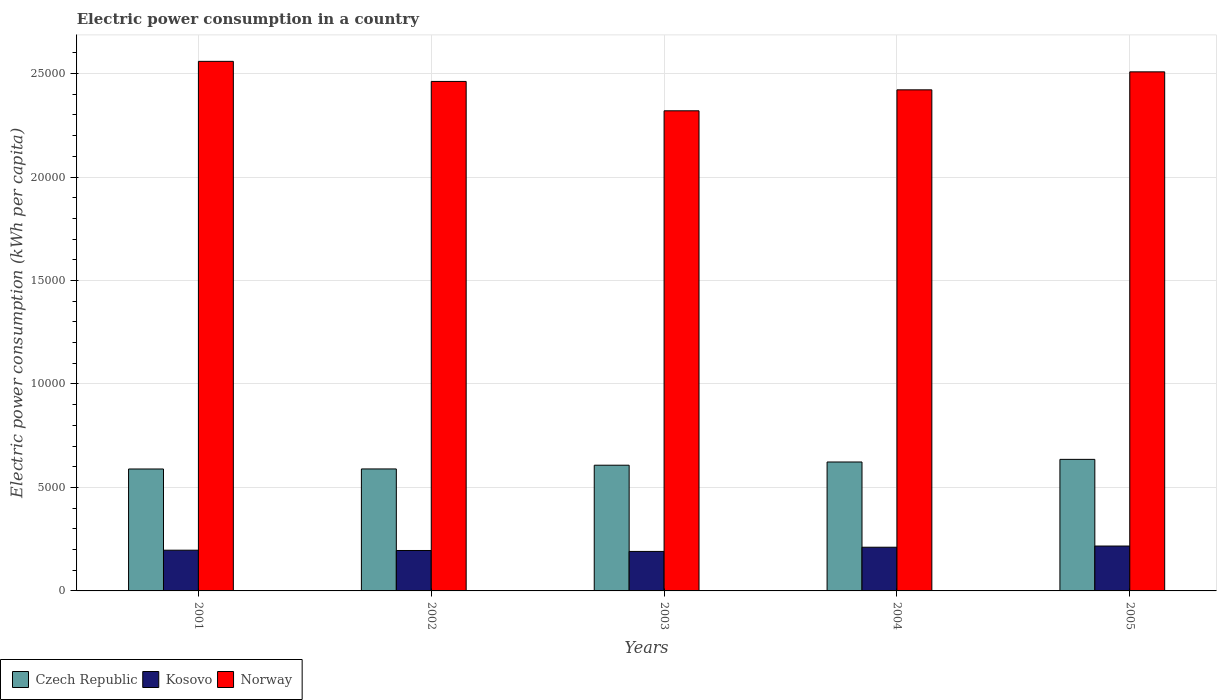How many bars are there on the 5th tick from the left?
Offer a very short reply. 3. How many bars are there on the 5th tick from the right?
Give a very brief answer. 3. What is the electric power consumption in in Czech Republic in 2005?
Your answer should be compact. 6357.42. Across all years, what is the maximum electric power consumption in in Kosovo?
Provide a succinct answer. 2169.1. Across all years, what is the minimum electric power consumption in in Czech Republic?
Give a very brief answer. 5892.17. In which year was the electric power consumption in in Norway maximum?
Give a very brief answer. 2001. In which year was the electric power consumption in in Kosovo minimum?
Provide a short and direct response. 2003. What is the total electric power consumption in in Norway in the graph?
Provide a short and direct response. 1.23e+05. What is the difference between the electric power consumption in in Kosovo in 2003 and that in 2005?
Your response must be concise. -260.63. What is the difference between the electric power consumption in in Czech Republic in 2001 and the electric power consumption in in Norway in 2002?
Provide a succinct answer. -1.87e+04. What is the average electric power consumption in in Czech Republic per year?
Ensure brevity in your answer.  6089.81. In the year 2002, what is the difference between the electric power consumption in in Kosovo and electric power consumption in in Norway?
Your answer should be compact. -2.27e+04. What is the ratio of the electric power consumption in in Czech Republic in 2002 to that in 2003?
Give a very brief answer. 0.97. Is the difference between the electric power consumption in in Kosovo in 2004 and 2005 greater than the difference between the electric power consumption in in Norway in 2004 and 2005?
Provide a short and direct response. Yes. What is the difference between the highest and the second highest electric power consumption in in Kosovo?
Your answer should be very brief. 57.78. What is the difference between the highest and the lowest electric power consumption in in Norway?
Your answer should be compact. 2389.3. Is the sum of the electric power consumption in in Norway in 2001 and 2004 greater than the maximum electric power consumption in in Czech Republic across all years?
Offer a terse response. Yes. What does the 1st bar from the left in 2001 represents?
Your answer should be very brief. Czech Republic. Are all the bars in the graph horizontal?
Make the answer very short. No. How many years are there in the graph?
Keep it short and to the point. 5. Where does the legend appear in the graph?
Offer a very short reply. Bottom left. How are the legend labels stacked?
Your answer should be compact. Horizontal. What is the title of the graph?
Make the answer very short. Electric power consumption in a country. Does "Panama" appear as one of the legend labels in the graph?
Offer a terse response. No. What is the label or title of the X-axis?
Provide a succinct answer. Years. What is the label or title of the Y-axis?
Provide a succinct answer. Electric power consumption (kWh per capita). What is the Electric power consumption (kWh per capita) of Czech Republic in 2001?
Keep it short and to the point. 5892.17. What is the Electric power consumption (kWh per capita) in Kosovo in 2001?
Give a very brief answer. 1968.08. What is the Electric power consumption (kWh per capita) of Norway in 2001?
Your response must be concise. 2.56e+04. What is the Electric power consumption (kWh per capita) in Czech Republic in 2002?
Your answer should be compact. 5894.23. What is the Electric power consumption (kWh per capita) in Kosovo in 2002?
Make the answer very short. 1953.82. What is the Electric power consumption (kWh per capita) in Norway in 2002?
Your answer should be compact. 2.46e+04. What is the Electric power consumption (kWh per capita) in Czech Republic in 2003?
Provide a succinct answer. 6074.85. What is the Electric power consumption (kWh per capita) in Kosovo in 2003?
Offer a very short reply. 1908.46. What is the Electric power consumption (kWh per capita) in Norway in 2003?
Give a very brief answer. 2.32e+04. What is the Electric power consumption (kWh per capita) of Czech Republic in 2004?
Keep it short and to the point. 6230.4. What is the Electric power consumption (kWh per capita) in Kosovo in 2004?
Your answer should be very brief. 2111.32. What is the Electric power consumption (kWh per capita) of Norway in 2004?
Ensure brevity in your answer.  2.42e+04. What is the Electric power consumption (kWh per capita) in Czech Republic in 2005?
Your answer should be compact. 6357.42. What is the Electric power consumption (kWh per capita) of Kosovo in 2005?
Your answer should be very brief. 2169.1. What is the Electric power consumption (kWh per capita) of Norway in 2005?
Offer a terse response. 2.51e+04. Across all years, what is the maximum Electric power consumption (kWh per capita) in Czech Republic?
Provide a short and direct response. 6357.42. Across all years, what is the maximum Electric power consumption (kWh per capita) in Kosovo?
Offer a very short reply. 2169.1. Across all years, what is the maximum Electric power consumption (kWh per capita) of Norway?
Provide a short and direct response. 2.56e+04. Across all years, what is the minimum Electric power consumption (kWh per capita) in Czech Republic?
Ensure brevity in your answer.  5892.17. Across all years, what is the minimum Electric power consumption (kWh per capita) of Kosovo?
Offer a terse response. 1908.46. Across all years, what is the minimum Electric power consumption (kWh per capita) of Norway?
Provide a short and direct response. 2.32e+04. What is the total Electric power consumption (kWh per capita) in Czech Republic in the graph?
Offer a terse response. 3.04e+04. What is the total Electric power consumption (kWh per capita) in Kosovo in the graph?
Ensure brevity in your answer.  1.01e+04. What is the total Electric power consumption (kWh per capita) of Norway in the graph?
Offer a very short reply. 1.23e+05. What is the difference between the Electric power consumption (kWh per capita) of Czech Republic in 2001 and that in 2002?
Give a very brief answer. -2.06. What is the difference between the Electric power consumption (kWh per capita) in Kosovo in 2001 and that in 2002?
Provide a short and direct response. 14.26. What is the difference between the Electric power consumption (kWh per capita) of Norway in 2001 and that in 2002?
Your answer should be compact. 970.35. What is the difference between the Electric power consumption (kWh per capita) of Czech Republic in 2001 and that in 2003?
Provide a short and direct response. -182.68. What is the difference between the Electric power consumption (kWh per capita) of Kosovo in 2001 and that in 2003?
Give a very brief answer. 59.61. What is the difference between the Electric power consumption (kWh per capita) of Norway in 2001 and that in 2003?
Ensure brevity in your answer.  2389.3. What is the difference between the Electric power consumption (kWh per capita) of Czech Republic in 2001 and that in 2004?
Ensure brevity in your answer.  -338.23. What is the difference between the Electric power consumption (kWh per capita) in Kosovo in 2001 and that in 2004?
Ensure brevity in your answer.  -143.24. What is the difference between the Electric power consumption (kWh per capita) of Norway in 2001 and that in 2004?
Keep it short and to the point. 1376.58. What is the difference between the Electric power consumption (kWh per capita) in Czech Republic in 2001 and that in 2005?
Make the answer very short. -465.25. What is the difference between the Electric power consumption (kWh per capita) of Kosovo in 2001 and that in 2005?
Make the answer very short. -201.02. What is the difference between the Electric power consumption (kWh per capita) of Norway in 2001 and that in 2005?
Offer a terse response. 507.47. What is the difference between the Electric power consumption (kWh per capita) of Czech Republic in 2002 and that in 2003?
Offer a very short reply. -180.62. What is the difference between the Electric power consumption (kWh per capita) of Kosovo in 2002 and that in 2003?
Your response must be concise. 45.35. What is the difference between the Electric power consumption (kWh per capita) of Norway in 2002 and that in 2003?
Provide a succinct answer. 1418.94. What is the difference between the Electric power consumption (kWh per capita) of Czech Republic in 2002 and that in 2004?
Make the answer very short. -336.17. What is the difference between the Electric power consumption (kWh per capita) of Kosovo in 2002 and that in 2004?
Your answer should be compact. -157.5. What is the difference between the Electric power consumption (kWh per capita) in Norway in 2002 and that in 2004?
Offer a very short reply. 406.23. What is the difference between the Electric power consumption (kWh per capita) in Czech Republic in 2002 and that in 2005?
Offer a very short reply. -463.19. What is the difference between the Electric power consumption (kWh per capita) of Kosovo in 2002 and that in 2005?
Ensure brevity in your answer.  -215.28. What is the difference between the Electric power consumption (kWh per capita) in Norway in 2002 and that in 2005?
Offer a very short reply. -462.88. What is the difference between the Electric power consumption (kWh per capita) in Czech Republic in 2003 and that in 2004?
Provide a short and direct response. -155.55. What is the difference between the Electric power consumption (kWh per capita) in Kosovo in 2003 and that in 2004?
Your response must be concise. -202.86. What is the difference between the Electric power consumption (kWh per capita) of Norway in 2003 and that in 2004?
Make the answer very short. -1012.71. What is the difference between the Electric power consumption (kWh per capita) in Czech Republic in 2003 and that in 2005?
Your answer should be very brief. -282.57. What is the difference between the Electric power consumption (kWh per capita) in Kosovo in 2003 and that in 2005?
Your response must be concise. -260.63. What is the difference between the Electric power consumption (kWh per capita) of Norway in 2003 and that in 2005?
Offer a very short reply. -1881.82. What is the difference between the Electric power consumption (kWh per capita) of Czech Republic in 2004 and that in 2005?
Provide a short and direct response. -127.02. What is the difference between the Electric power consumption (kWh per capita) of Kosovo in 2004 and that in 2005?
Your answer should be compact. -57.78. What is the difference between the Electric power consumption (kWh per capita) in Norway in 2004 and that in 2005?
Ensure brevity in your answer.  -869.11. What is the difference between the Electric power consumption (kWh per capita) in Czech Republic in 2001 and the Electric power consumption (kWh per capita) in Kosovo in 2002?
Give a very brief answer. 3938.36. What is the difference between the Electric power consumption (kWh per capita) of Czech Republic in 2001 and the Electric power consumption (kWh per capita) of Norway in 2002?
Offer a terse response. -1.87e+04. What is the difference between the Electric power consumption (kWh per capita) in Kosovo in 2001 and the Electric power consumption (kWh per capita) in Norway in 2002?
Make the answer very short. -2.27e+04. What is the difference between the Electric power consumption (kWh per capita) of Czech Republic in 2001 and the Electric power consumption (kWh per capita) of Kosovo in 2003?
Make the answer very short. 3983.71. What is the difference between the Electric power consumption (kWh per capita) in Czech Republic in 2001 and the Electric power consumption (kWh per capita) in Norway in 2003?
Your answer should be very brief. -1.73e+04. What is the difference between the Electric power consumption (kWh per capita) of Kosovo in 2001 and the Electric power consumption (kWh per capita) of Norway in 2003?
Offer a terse response. -2.12e+04. What is the difference between the Electric power consumption (kWh per capita) of Czech Republic in 2001 and the Electric power consumption (kWh per capita) of Kosovo in 2004?
Your answer should be very brief. 3780.85. What is the difference between the Electric power consumption (kWh per capita) in Czech Republic in 2001 and the Electric power consumption (kWh per capita) in Norway in 2004?
Offer a terse response. -1.83e+04. What is the difference between the Electric power consumption (kWh per capita) in Kosovo in 2001 and the Electric power consumption (kWh per capita) in Norway in 2004?
Your response must be concise. -2.22e+04. What is the difference between the Electric power consumption (kWh per capita) in Czech Republic in 2001 and the Electric power consumption (kWh per capita) in Kosovo in 2005?
Ensure brevity in your answer.  3723.08. What is the difference between the Electric power consumption (kWh per capita) of Czech Republic in 2001 and the Electric power consumption (kWh per capita) of Norway in 2005?
Provide a succinct answer. -1.92e+04. What is the difference between the Electric power consumption (kWh per capita) of Kosovo in 2001 and the Electric power consumption (kWh per capita) of Norway in 2005?
Keep it short and to the point. -2.31e+04. What is the difference between the Electric power consumption (kWh per capita) in Czech Republic in 2002 and the Electric power consumption (kWh per capita) in Kosovo in 2003?
Your answer should be compact. 3985.77. What is the difference between the Electric power consumption (kWh per capita) of Czech Republic in 2002 and the Electric power consumption (kWh per capita) of Norway in 2003?
Offer a very short reply. -1.73e+04. What is the difference between the Electric power consumption (kWh per capita) in Kosovo in 2002 and the Electric power consumption (kWh per capita) in Norway in 2003?
Offer a terse response. -2.12e+04. What is the difference between the Electric power consumption (kWh per capita) of Czech Republic in 2002 and the Electric power consumption (kWh per capita) of Kosovo in 2004?
Offer a very short reply. 3782.91. What is the difference between the Electric power consumption (kWh per capita) in Czech Republic in 2002 and the Electric power consumption (kWh per capita) in Norway in 2004?
Offer a terse response. -1.83e+04. What is the difference between the Electric power consumption (kWh per capita) in Kosovo in 2002 and the Electric power consumption (kWh per capita) in Norway in 2004?
Provide a succinct answer. -2.23e+04. What is the difference between the Electric power consumption (kWh per capita) in Czech Republic in 2002 and the Electric power consumption (kWh per capita) in Kosovo in 2005?
Keep it short and to the point. 3725.14. What is the difference between the Electric power consumption (kWh per capita) of Czech Republic in 2002 and the Electric power consumption (kWh per capita) of Norway in 2005?
Ensure brevity in your answer.  -1.92e+04. What is the difference between the Electric power consumption (kWh per capita) in Kosovo in 2002 and the Electric power consumption (kWh per capita) in Norway in 2005?
Provide a succinct answer. -2.31e+04. What is the difference between the Electric power consumption (kWh per capita) in Czech Republic in 2003 and the Electric power consumption (kWh per capita) in Kosovo in 2004?
Your response must be concise. 3963.53. What is the difference between the Electric power consumption (kWh per capita) of Czech Republic in 2003 and the Electric power consumption (kWh per capita) of Norway in 2004?
Your answer should be very brief. -1.81e+04. What is the difference between the Electric power consumption (kWh per capita) of Kosovo in 2003 and the Electric power consumption (kWh per capita) of Norway in 2004?
Ensure brevity in your answer.  -2.23e+04. What is the difference between the Electric power consumption (kWh per capita) of Czech Republic in 2003 and the Electric power consumption (kWh per capita) of Kosovo in 2005?
Your response must be concise. 3905.75. What is the difference between the Electric power consumption (kWh per capita) of Czech Republic in 2003 and the Electric power consumption (kWh per capita) of Norway in 2005?
Provide a short and direct response. -1.90e+04. What is the difference between the Electric power consumption (kWh per capita) in Kosovo in 2003 and the Electric power consumption (kWh per capita) in Norway in 2005?
Give a very brief answer. -2.32e+04. What is the difference between the Electric power consumption (kWh per capita) of Czech Republic in 2004 and the Electric power consumption (kWh per capita) of Kosovo in 2005?
Keep it short and to the point. 4061.3. What is the difference between the Electric power consumption (kWh per capita) in Czech Republic in 2004 and the Electric power consumption (kWh per capita) in Norway in 2005?
Offer a very short reply. -1.89e+04. What is the difference between the Electric power consumption (kWh per capita) of Kosovo in 2004 and the Electric power consumption (kWh per capita) of Norway in 2005?
Ensure brevity in your answer.  -2.30e+04. What is the average Electric power consumption (kWh per capita) of Czech Republic per year?
Give a very brief answer. 6089.81. What is the average Electric power consumption (kWh per capita) of Kosovo per year?
Keep it short and to the point. 2022.15. What is the average Electric power consumption (kWh per capita) in Norway per year?
Your answer should be compact. 2.45e+04. In the year 2001, what is the difference between the Electric power consumption (kWh per capita) of Czech Republic and Electric power consumption (kWh per capita) of Kosovo?
Give a very brief answer. 3924.1. In the year 2001, what is the difference between the Electric power consumption (kWh per capita) in Czech Republic and Electric power consumption (kWh per capita) in Norway?
Ensure brevity in your answer.  -1.97e+04. In the year 2001, what is the difference between the Electric power consumption (kWh per capita) in Kosovo and Electric power consumption (kWh per capita) in Norway?
Offer a terse response. -2.36e+04. In the year 2002, what is the difference between the Electric power consumption (kWh per capita) in Czech Republic and Electric power consumption (kWh per capita) in Kosovo?
Your response must be concise. 3940.42. In the year 2002, what is the difference between the Electric power consumption (kWh per capita) of Czech Republic and Electric power consumption (kWh per capita) of Norway?
Provide a succinct answer. -1.87e+04. In the year 2002, what is the difference between the Electric power consumption (kWh per capita) of Kosovo and Electric power consumption (kWh per capita) of Norway?
Give a very brief answer. -2.27e+04. In the year 2003, what is the difference between the Electric power consumption (kWh per capita) of Czech Republic and Electric power consumption (kWh per capita) of Kosovo?
Offer a terse response. 4166.39. In the year 2003, what is the difference between the Electric power consumption (kWh per capita) in Czech Republic and Electric power consumption (kWh per capita) in Norway?
Provide a succinct answer. -1.71e+04. In the year 2003, what is the difference between the Electric power consumption (kWh per capita) in Kosovo and Electric power consumption (kWh per capita) in Norway?
Offer a terse response. -2.13e+04. In the year 2004, what is the difference between the Electric power consumption (kWh per capita) of Czech Republic and Electric power consumption (kWh per capita) of Kosovo?
Keep it short and to the point. 4119.08. In the year 2004, what is the difference between the Electric power consumption (kWh per capita) in Czech Republic and Electric power consumption (kWh per capita) in Norway?
Give a very brief answer. -1.80e+04. In the year 2004, what is the difference between the Electric power consumption (kWh per capita) in Kosovo and Electric power consumption (kWh per capita) in Norway?
Ensure brevity in your answer.  -2.21e+04. In the year 2005, what is the difference between the Electric power consumption (kWh per capita) of Czech Republic and Electric power consumption (kWh per capita) of Kosovo?
Your answer should be compact. 4188.33. In the year 2005, what is the difference between the Electric power consumption (kWh per capita) of Czech Republic and Electric power consumption (kWh per capita) of Norway?
Offer a terse response. -1.87e+04. In the year 2005, what is the difference between the Electric power consumption (kWh per capita) of Kosovo and Electric power consumption (kWh per capita) of Norway?
Your answer should be very brief. -2.29e+04. What is the ratio of the Electric power consumption (kWh per capita) of Czech Republic in 2001 to that in 2002?
Provide a short and direct response. 1. What is the ratio of the Electric power consumption (kWh per capita) in Kosovo in 2001 to that in 2002?
Provide a short and direct response. 1.01. What is the ratio of the Electric power consumption (kWh per capita) of Norway in 2001 to that in 2002?
Ensure brevity in your answer.  1.04. What is the ratio of the Electric power consumption (kWh per capita) in Czech Republic in 2001 to that in 2003?
Make the answer very short. 0.97. What is the ratio of the Electric power consumption (kWh per capita) in Kosovo in 2001 to that in 2003?
Provide a succinct answer. 1.03. What is the ratio of the Electric power consumption (kWh per capita) in Norway in 2001 to that in 2003?
Ensure brevity in your answer.  1.1. What is the ratio of the Electric power consumption (kWh per capita) in Czech Republic in 2001 to that in 2004?
Your answer should be compact. 0.95. What is the ratio of the Electric power consumption (kWh per capita) of Kosovo in 2001 to that in 2004?
Give a very brief answer. 0.93. What is the ratio of the Electric power consumption (kWh per capita) in Norway in 2001 to that in 2004?
Offer a very short reply. 1.06. What is the ratio of the Electric power consumption (kWh per capita) in Czech Republic in 2001 to that in 2005?
Offer a very short reply. 0.93. What is the ratio of the Electric power consumption (kWh per capita) in Kosovo in 2001 to that in 2005?
Provide a succinct answer. 0.91. What is the ratio of the Electric power consumption (kWh per capita) in Norway in 2001 to that in 2005?
Provide a short and direct response. 1.02. What is the ratio of the Electric power consumption (kWh per capita) in Czech Republic in 2002 to that in 2003?
Your response must be concise. 0.97. What is the ratio of the Electric power consumption (kWh per capita) in Kosovo in 2002 to that in 2003?
Your answer should be very brief. 1.02. What is the ratio of the Electric power consumption (kWh per capita) of Norway in 2002 to that in 2003?
Provide a succinct answer. 1.06. What is the ratio of the Electric power consumption (kWh per capita) of Czech Republic in 2002 to that in 2004?
Your answer should be very brief. 0.95. What is the ratio of the Electric power consumption (kWh per capita) in Kosovo in 2002 to that in 2004?
Offer a terse response. 0.93. What is the ratio of the Electric power consumption (kWh per capita) of Norway in 2002 to that in 2004?
Provide a short and direct response. 1.02. What is the ratio of the Electric power consumption (kWh per capita) of Czech Republic in 2002 to that in 2005?
Your response must be concise. 0.93. What is the ratio of the Electric power consumption (kWh per capita) in Kosovo in 2002 to that in 2005?
Your answer should be very brief. 0.9. What is the ratio of the Electric power consumption (kWh per capita) in Norway in 2002 to that in 2005?
Provide a succinct answer. 0.98. What is the ratio of the Electric power consumption (kWh per capita) of Kosovo in 2003 to that in 2004?
Your response must be concise. 0.9. What is the ratio of the Electric power consumption (kWh per capita) in Norway in 2003 to that in 2004?
Ensure brevity in your answer.  0.96. What is the ratio of the Electric power consumption (kWh per capita) in Czech Republic in 2003 to that in 2005?
Keep it short and to the point. 0.96. What is the ratio of the Electric power consumption (kWh per capita) in Kosovo in 2003 to that in 2005?
Make the answer very short. 0.88. What is the ratio of the Electric power consumption (kWh per capita) of Norway in 2003 to that in 2005?
Give a very brief answer. 0.93. What is the ratio of the Electric power consumption (kWh per capita) of Kosovo in 2004 to that in 2005?
Ensure brevity in your answer.  0.97. What is the ratio of the Electric power consumption (kWh per capita) of Norway in 2004 to that in 2005?
Your answer should be very brief. 0.97. What is the difference between the highest and the second highest Electric power consumption (kWh per capita) in Czech Republic?
Give a very brief answer. 127.02. What is the difference between the highest and the second highest Electric power consumption (kWh per capita) in Kosovo?
Make the answer very short. 57.78. What is the difference between the highest and the second highest Electric power consumption (kWh per capita) of Norway?
Ensure brevity in your answer.  507.47. What is the difference between the highest and the lowest Electric power consumption (kWh per capita) in Czech Republic?
Provide a succinct answer. 465.25. What is the difference between the highest and the lowest Electric power consumption (kWh per capita) of Kosovo?
Your answer should be compact. 260.63. What is the difference between the highest and the lowest Electric power consumption (kWh per capita) of Norway?
Give a very brief answer. 2389.3. 